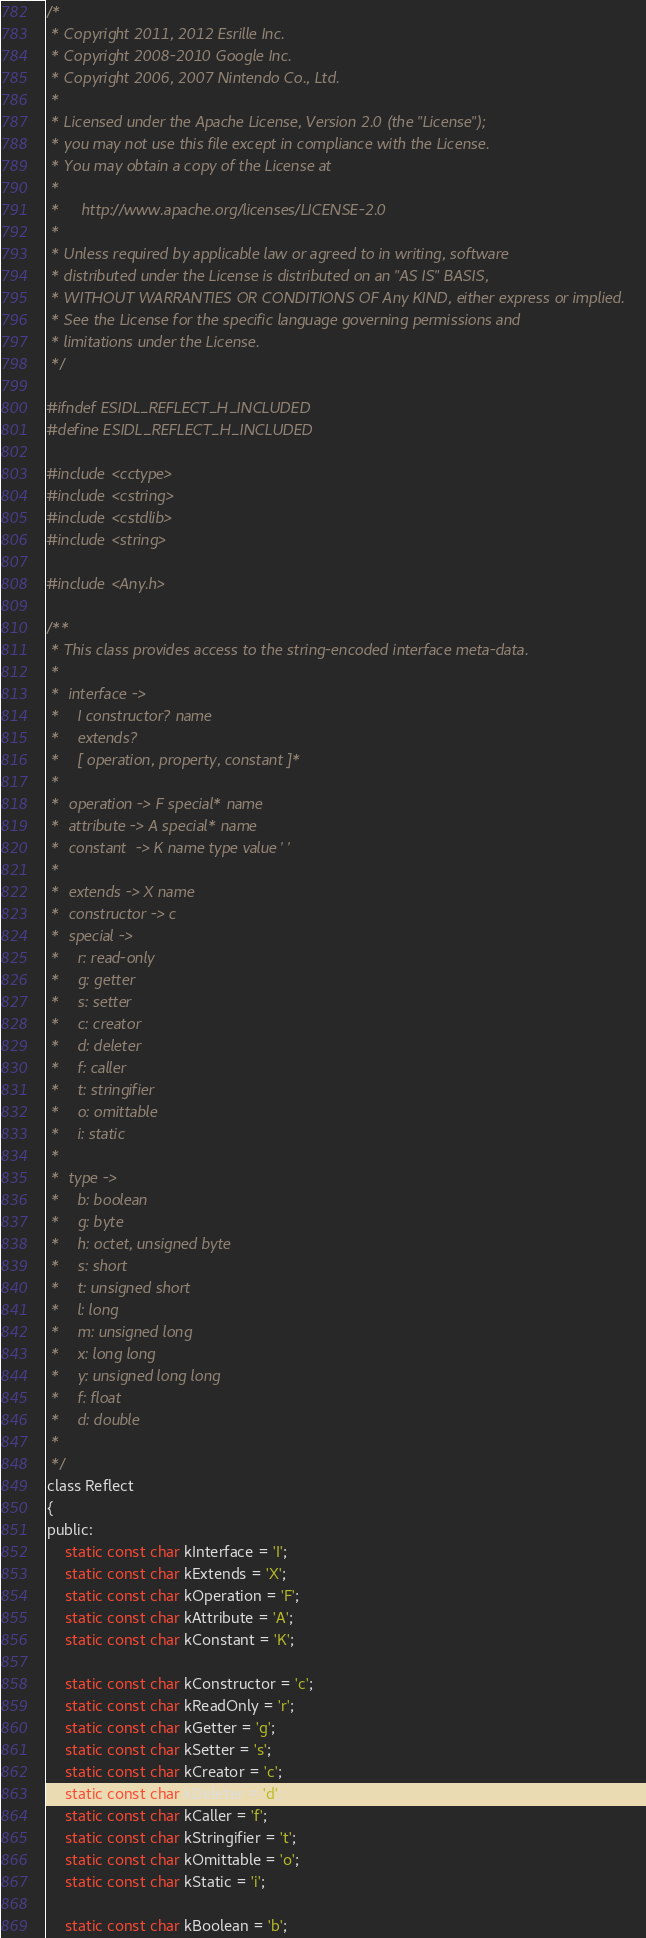Convert code to text. <code><loc_0><loc_0><loc_500><loc_500><_C_>/*
 * Copyright 2011, 2012 Esrille Inc.
 * Copyright 2008-2010 Google Inc.
 * Copyright 2006, 2007 Nintendo Co., Ltd.
 *
 * Licensed under the Apache License, Version 2.0 (the "License");
 * you may not use this file except in compliance with the License.
 * You may obtain a copy of the License at
 *
 *     http://www.apache.org/licenses/LICENSE-2.0
 *
 * Unless required by applicable law or agreed to in writing, software
 * distributed under the License is distributed on an "AS IS" BASIS,
 * WITHOUT WARRANTIES OR CONDITIONS OF Any KIND, either express or implied.
 * See the License for the specific language governing permissions and
 * limitations under the License.
 */

#ifndef ESIDL_REFLECT_H_INCLUDED
#define ESIDL_REFLECT_H_INCLUDED

#include <cctype>
#include <cstring>
#include <cstdlib>
#include <string>

#include <Any.h>

/**
 * This class provides access to the string-encoded interface meta-data.
 *
 *  interface ->
 *    I constructor? name
 *    extends?
 *    [ operation, property, constant ]*
 *
 *  operation -> F special* name
 *  attribute -> A special* name
 *  constant  -> K name type value ' '
 *
 *  extends -> X name
 *  constructor -> c
 *  special ->
 *    r: read-only
 *    g: getter
 *    s: setter
 *    c: creator
 *    d: deleter
 *    f: caller
 *    t: stringifier
 *    o: omittable
 *    i: static
 *
 *  type ->
 *    b: boolean
 *    g: byte
 *    h: octet, unsigned byte
 *    s: short
 *    t: unsigned short
 *    l: long
 *    m: unsigned long
 *    x: long long
 *    y: unsigned long long
 *    f: float
 *    d: double
 *
 */
class Reflect
{
public:
    static const char kInterface = 'I';
    static const char kExtends = 'X';
    static const char kOperation = 'F';
    static const char kAttribute = 'A';
    static const char kConstant = 'K';

    static const char kConstructor = 'c';
    static const char kReadOnly = 'r';
    static const char kGetter = 'g';
    static const char kSetter = 's';
    static const char kCreator = 'c';
    static const char kDeleter = 'd';
    static const char kCaller = 'f';
    static const char kStringifier = 't';
    static const char kOmittable = 'o';
    static const char kStatic = 'i';

    static const char kBoolean = 'b';</code> 